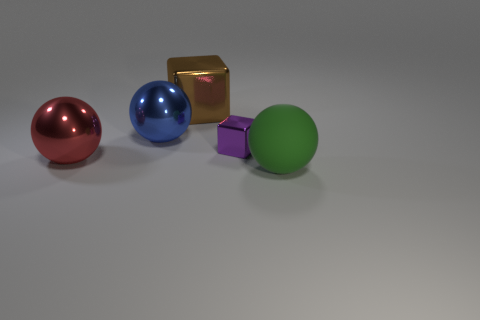How big is the metal sphere that is to the right of the large metallic ball in front of the metallic object that is to the right of the big brown block?
Your answer should be compact. Large. There is another object that is the same shape as the big brown shiny thing; what is its color?
Make the answer very short. Purple. Are there more tiny purple shiny cubes in front of the brown object than large cyan objects?
Your response must be concise. Yes. Does the large brown thing have the same shape as the big thing in front of the red metallic sphere?
Make the answer very short. No. Are there any other things that have the same size as the purple cube?
Ensure brevity in your answer.  No. What size is the red metallic object that is the same shape as the large rubber thing?
Your response must be concise. Large. Is the number of red shiny spheres greater than the number of blocks?
Provide a succinct answer. No. Is the matte object the same shape as the big blue shiny object?
Offer a terse response. Yes. What is the ball on the right side of the metallic block that is right of the large brown metal object made of?
Provide a short and direct response. Rubber. Do the purple shiny object and the blue object have the same size?
Provide a short and direct response. No. 